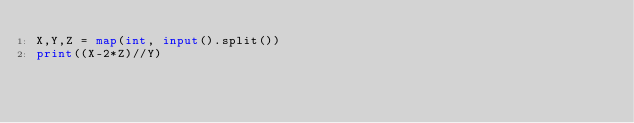<code> <loc_0><loc_0><loc_500><loc_500><_Python_>X,Y,Z = map(int, input().split())
print((X-2*Z)//Y)</code> 